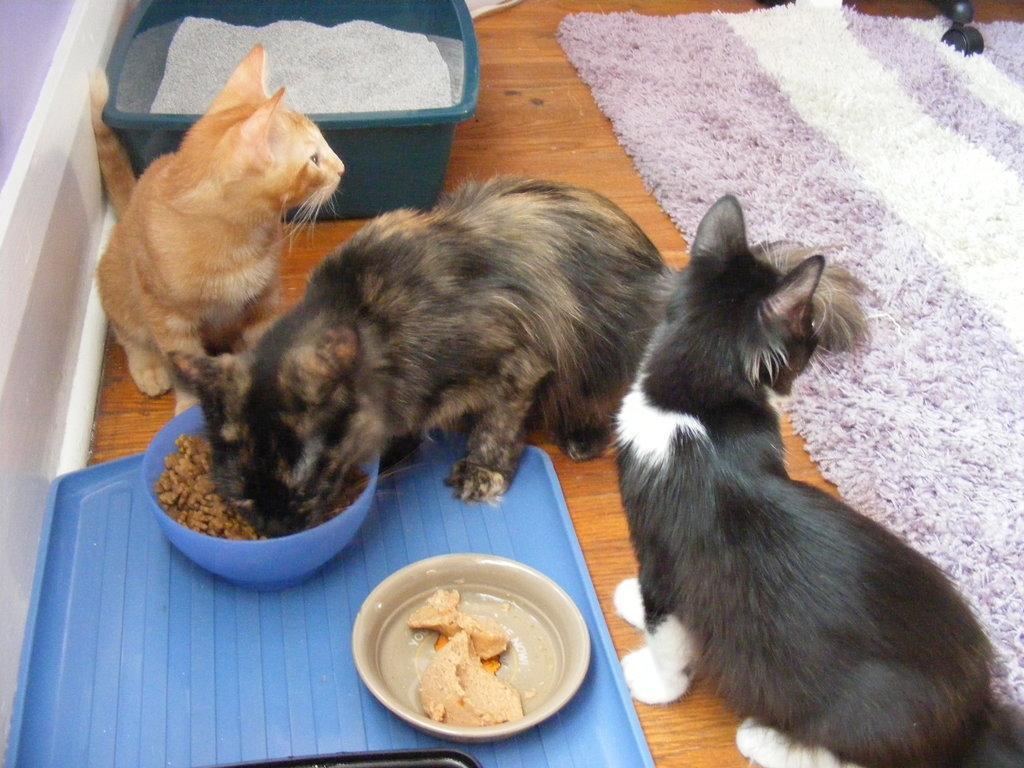Can you describe this image briefly? In this image there are three cats, there is a plate towards the bottom of the image, there are bowls, there is food in the bowls, there is a wooden floor, there is a cloth towards the right of the image, there is an object towards the top of the image, there is an object that looks like a container, there is a cloth in the container. 